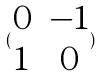<formula> <loc_0><loc_0><loc_500><loc_500>( \begin{matrix} 0 & - 1 \\ 1 & 0 \end{matrix} )</formula> 